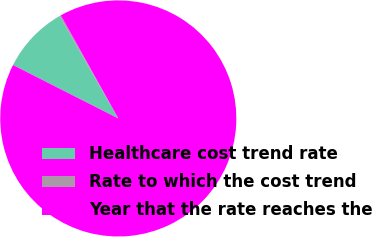Convert chart to OTSL. <chart><loc_0><loc_0><loc_500><loc_500><pie_chart><fcel>Healthcare cost trend rate<fcel>Rate to which the cost trend<fcel>Year that the rate reaches the<nl><fcel>9.24%<fcel>0.2%<fcel>90.56%<nl></chart> 